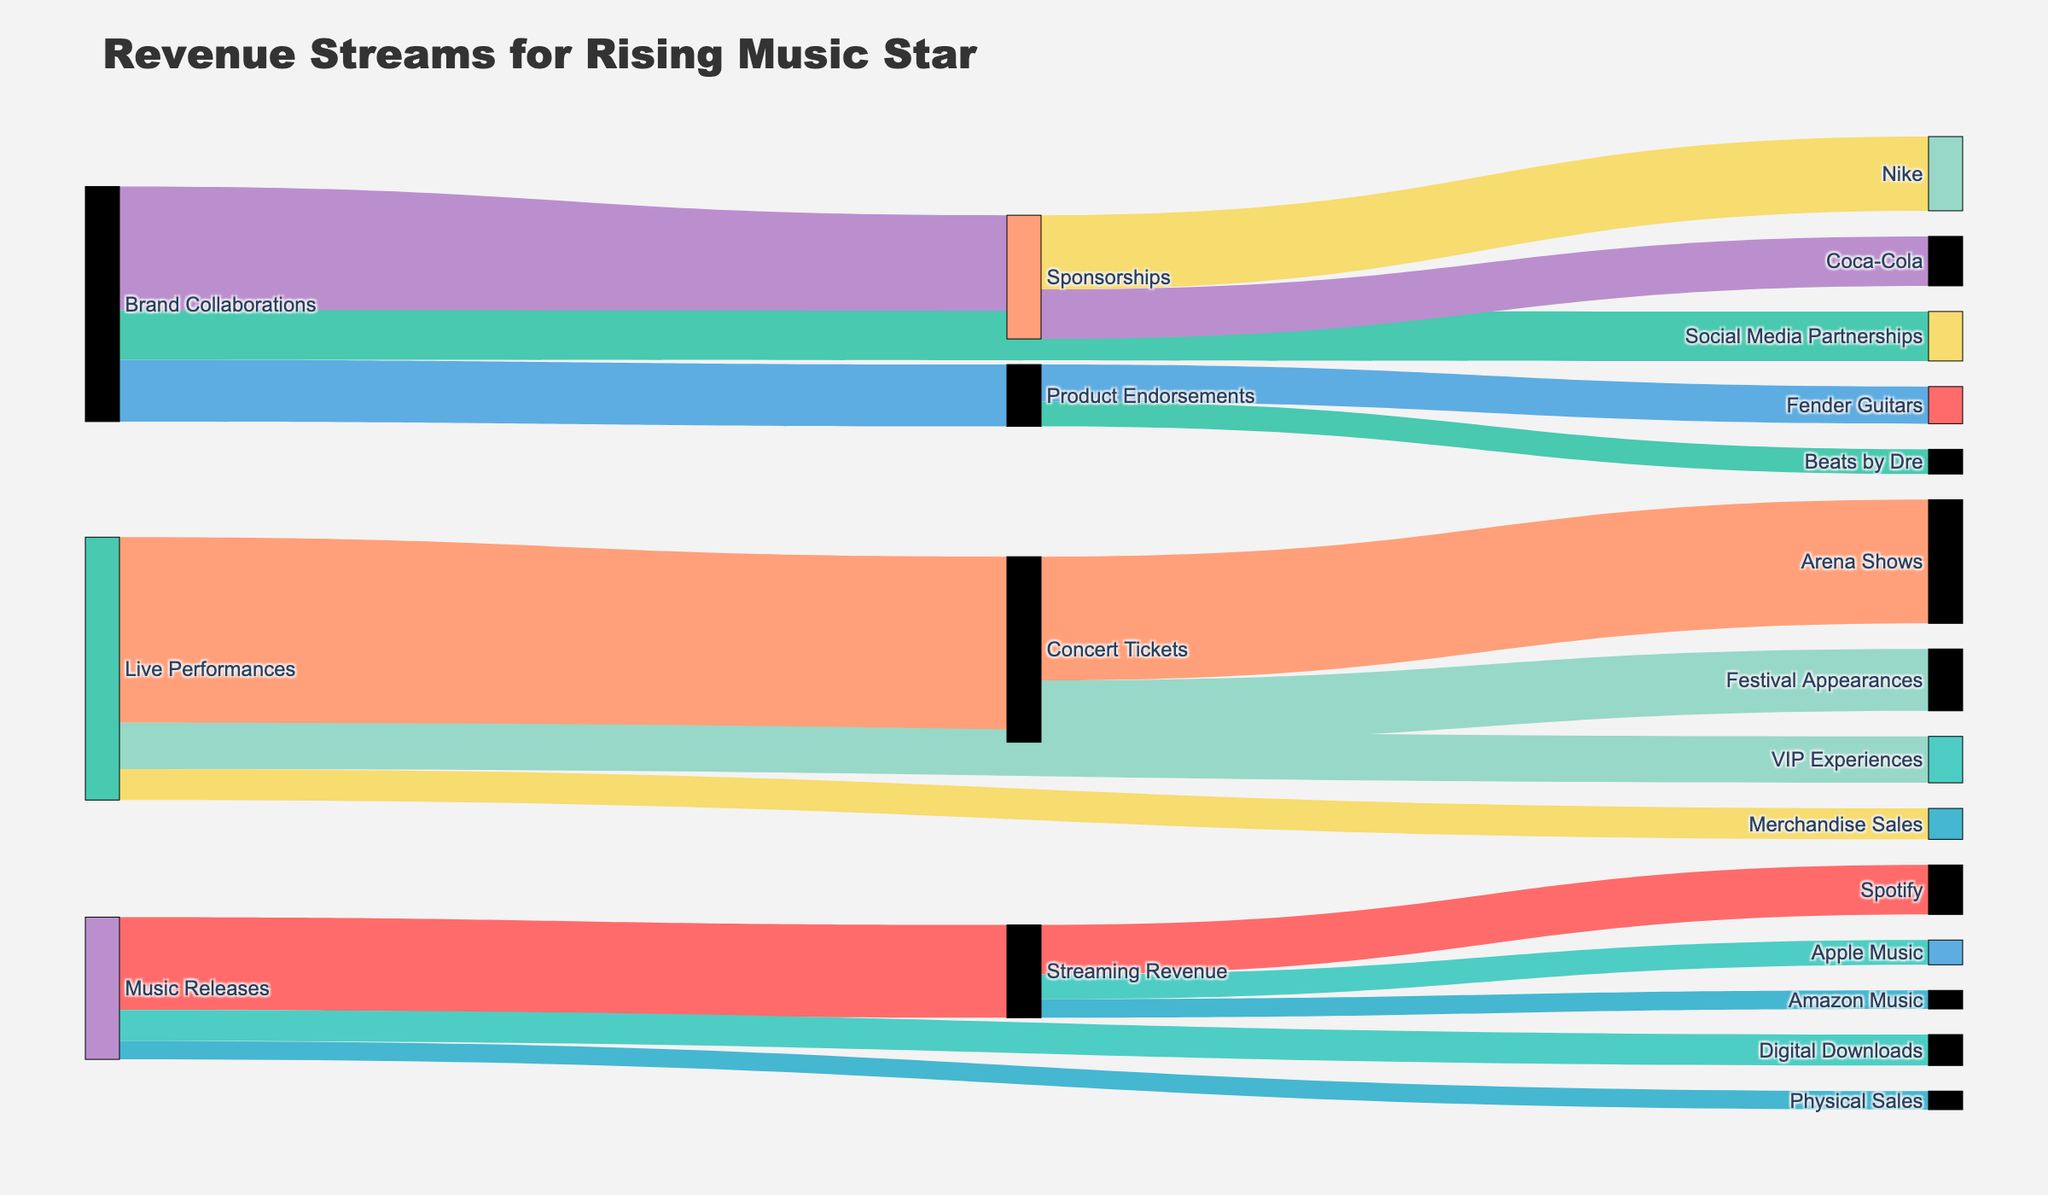What's the total revenue generated from music releases? To find the total revenue for music releases, sum up the values from all the targets under 'Music Releases': Streaming Revenue (150,000), Digital Downloads (50,000), and Physical Sales (30,000). 150,000 + 50,000 + 30,000 = 230,000
Answer: 230,000 Which brand collaboration stream generates the most revenue? Compare the values for the three targets under 'Brand Collaborations': Sponsorships (200,000), Product Endorsements (100,000), and Social Media Partnerships (80,000). The highest value is 200,000 from Sponsorships.
Answer: Sponsorships How does the revenue from concert tickets compare to revenue from digital downloads? Identify the values for 'Concert Tickets' (300,000) and 'Digital Downloads' (50,000). Compare the two values: 300,000 (Concert Tickets) is greater than 50,000 (Digital Downloads).
Answer: Concert Tickets generate more revenue than Digital Downloads What is the combined revenue from social media partnerships and VIP experiences? Sum the values of 'Social Media Partnerships' (80,000) and 'VIP Experiences' (75,000). 80,000 + 75,000 = 155,000
Answer: 155,000 List all the sources generating revenue for streaming services. Look at the targets under 'Streaming Revenue'. They are Spotify (80,000), Apple Music (40,000), and Amazon Music (30,000).
Answer: Spotify, Apple Music, Amazon Music What's the difference in revenue between Apple Music and Amazon Music? Identify the values for 'Apple Music' (40,000) and 'Amazon Music' (30,000). Subtract the smaller value from the larger value: 40,000 - 30,000 = 10,000
Answer: 10,000 Which live performance revenue source contributes the least, and what is its value? Compare the values for the targets under 'Live Performances': Concert Tickets (300,000), VIP Experiences (75,000), and Merchandise Sales (50,000). The least value is 50,000 from Merchandise Sales.
Answer: Merchandise Sales, 50,000 How much total revenue is generated from sponsorships with Nike and Coca-Cola combined? Sum the values of 'Nike' (120,000) and 'Coca-Cola' (80,000). 120,000 + 80,000 = 200,000
Answer: 200,000 Calculate the total revenue from all the sources. Sum up all the values: 150,000 (Streaming Revenue) + 50,000 (Digital Downloads) + 30,000 (Physical Sales) + 300,000 (Concert Tickets) + 75,000 (VIP Experiences) + 50,000 (Merchandise Sales) + 200,000 (Sponsorships) + 100,000 (Product Endorsements) + 80,000 (Social Media Partnerships). Hence, 150,000 + 50,000 + 30,000 + 300,000 + 75,000 + 50,000 + 200,000 + 100,000 + 80,000 = 1,035,000
Answer: 1,035,000 